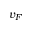Convert formula to latex. <formula><loc_0><loc_0><loc_500><loc_500>v _ { F }</formula> 